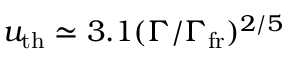Convert formula to latex. <formula><loc_0><loc_0><loc_500><loc_500>u _ { t h } \simeq 3 . 1 ( \Gamma / \Gamma _ { f r } ) ^ { 2 / 5 }</formula> 